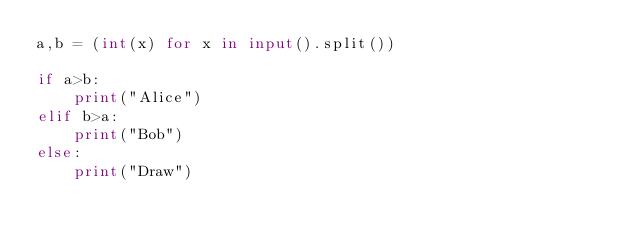<code> <loc_0><loc_0><loc_500><loc_500><_Python_>a,b = (int(x) for x in input().split())

if a>b:
    print("Alice")
elif b>a:
    print("Bob")
else:
    print("Draw")</code> 